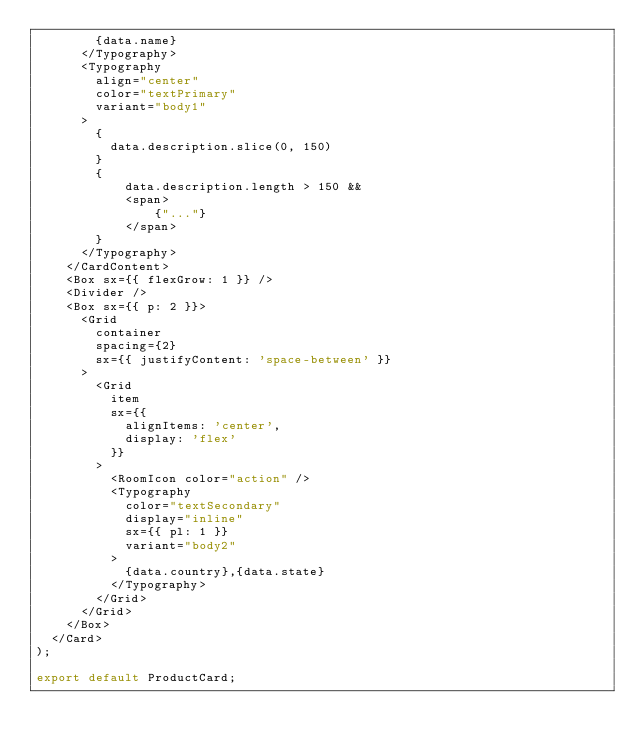Convert code to text. <code><loc_0><loc_0><loc_500><loc_500><_JavaScript_>        {data.name}
      </Typography>
      <Typography
        align="center"
        color="textPrimary"
        variant="body1"
      >
        {
          data.description.slice(0, 150) 
        }
        {
            data.description.length > 150 &&
            <span>
                {"..."}
            </span>
        }
      </Typography>
    </CardContent>
    <Box sx={{ flexGrow: 1 }} />
    <Divider />
    <Box sx={{ p: 2 }}>
      <Grid
        container
        spacing={2}
        sx={{ justifyContent: 'space-between' }}
      >
        <Grid
          item
          sx={{
            alignItems: 'center',
            display: 'flex'
          }}
        >
          <RoomIcon color="action" />
          <Typography
            color="textSecondary"
            display="inline"
            sx={{ pl: 1 }}
            variant="body2"
          >
            {data.country},{data.state}
          </Typography>
        </Grid>
      </Grid>
    </Box>
  </Card>
);

export default ProductCard;
</code> 